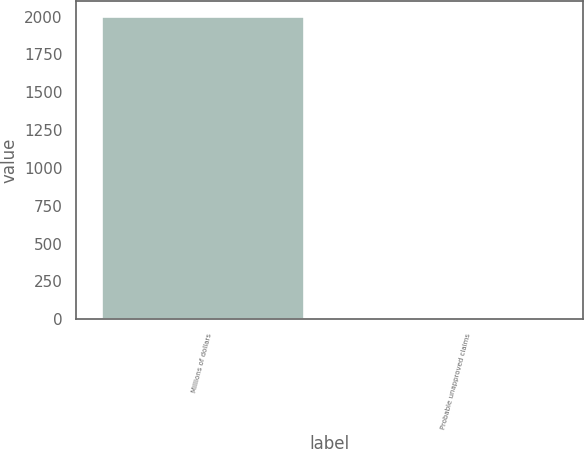Convert chart. <chart><loc_0><loc_0><loc_500><loc_500><bar_chart><fcel>Millions of dollars<fcel>Probable unapproved claims<nl><fcel>2003<fcel>10<nl></chart> 